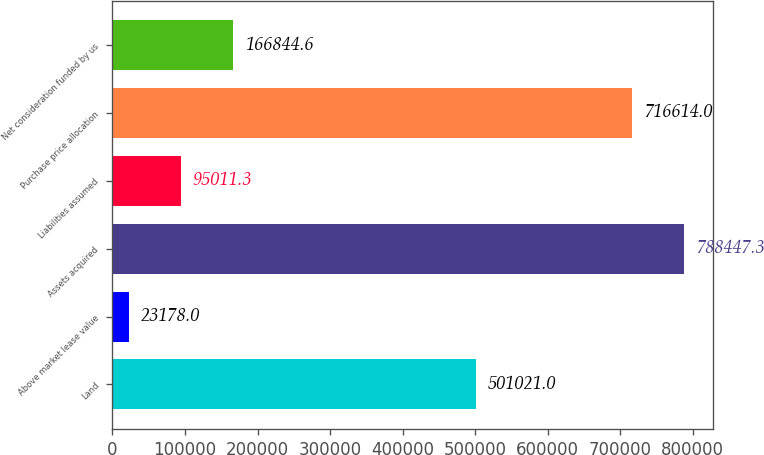Convert chart. <chart><loc_0><loc_0><loc_500><loc_500><bar_chart><fcel>Land<fcel>Above market lease value<fcel>Assets acquired<fcel>Liabilities assumed<fcel>Purchase price allocation<fcel>Net consideration funded by us<nl><fcel>501021<fcel>23178<fcel>788447<fcel>95011.3<fcel>716614<fcel>166845<nl></chart> 